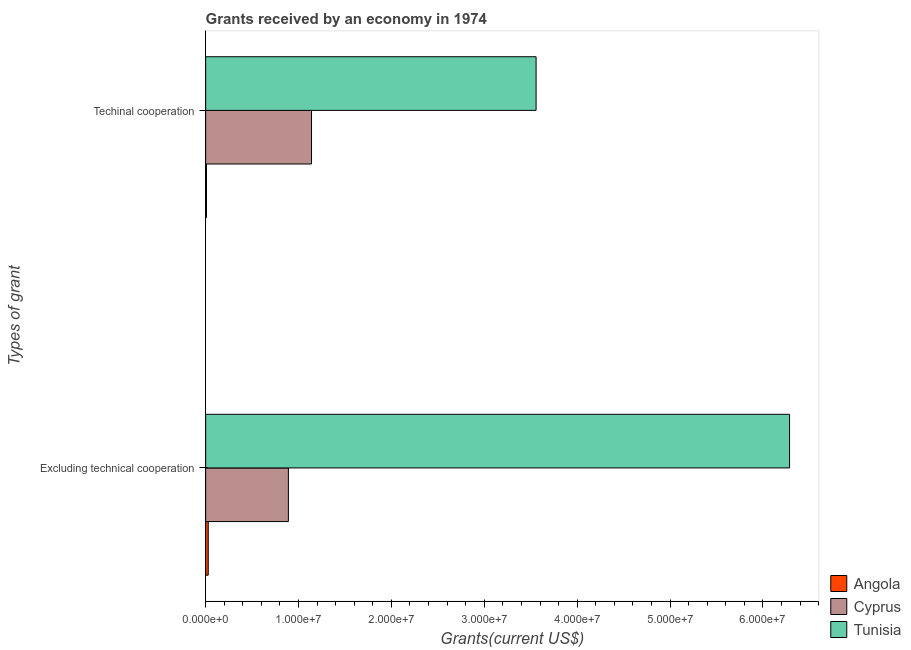How many groups of bars are there?
Make the answer very short. 2. What is the label of the 1st group of bars from the top?
Offer a very short reply. Techinal cooperation. What is the amount of grants received(including technical cooperation) in Tunisia?
Provide a succinct answer. 3.56e+07. Across all countries, what is the maximum amount of grants received(including technical cooperation)?
Your answer should be very brief. 3.56e+07. Across all countries, what is the minimum amount of grants received(excluding technical cooperation)?
Your answer should be compact. 2.80e+05. In which country was the amount of grants received(including technical cooperation) maximum?
Your answer should be compact. Tunisia. In which country was the amount of grants received(excluding technical cooperation) minimum?
Your response must be concise. Angola. What is the total amount of grants received(including technical cooperation) in the graph?
Offer a terse response. 4.71e+07. What is the difference between the amount of grants received(including technical cooperation) in Cyprus and that in Tunisia?
Ensure brevity in your answer.  -2.42e+07. What is the difference between the amount of grants received(including technical cooperation) in Cyprus and the amount of grants received(excluding technical cooperation) in Angola?
Your answer should be compact. 1.11e+07. What is the average amount of grants received(including technical cooperation) per country?
Make the answer very short. 1.57e+07. What is the difference between the amount of grants received(excluding technical cooperation) and amount of grants received(including technical cooperation) in Tunisia?
Your answer should be compact. 2.73e+07. What is the ratio of the amount of grants received(excluding technical cooperation) in Cyprus to that in Tunisia?
Offer a terse response. 0.14. Is the amount of grants received(including technical cooperation) in Tunisia less than that in Angola?
Your answer should be compact. No. What does the 1st bar from the top in Excluding technical cooperation represents?
Provide a succinct answer. Tunisia. What does the 3rd bar from the bottom in Excluding technical cooperation represents?
Your answer should be compact. Tunisia. Are all the bars in the graph horizontal?
Make the answer very short. Yes. How many countries are there in the graph?
Your response must be concise. 3. What is the difference between two consecutive major ticks on the X-axis?
Give a very brief answer. 1.00e+07. How many legend labels are there?
Make the answer very short. 3. What is the title of the graph?
Your answer should be compact. Grants received by an economy in 1974. What is the label or title of the X-axis?
Give a very brief answer. Grants(current US$). What is the label or title of the Y-axis?
Give a very brief answer. Types of grant. What is the Grants(current US$) in Angola in Excluding technical cooperation?
Give a very brief answer. 2.80e+05. What is the Grants(current US$) in Cyprus in Excluding technical cooperation?
Your answer should be very brief. 8.91e+06. What is the Grants(current US$) of Tunisia in Excluding technical cooperation?
Offer a very short reply. 6.29e+07. What is the Grants(current US$) in Cyprus in Techinal cooperation?
Offer a terse response. 1.14e+07. What is the Grants(current US$) in Tunisia in Techinal cooperation?
Your response must be concise. 3.56e+07. Across all Types of grant, what is the maximum Grants(current US$) in Cyprus?
Ensure brevity in your answer.  1.14e+07. Across all Types of grant, what is the maximum Grants(current US$) in Tunisia?
Offer a terse response. 6.29e+07. Across all Types of grant, what is the minimum Grants(current US$) in Angola?
Offer a very short reply. 9.00e+04. Across all Types of grant, what is the minimum Grants(current US$) of Cyprus?
Your answer should be compact. 8.91e+06. Across all Types of grant, what is the minimum Grants(current US$) in Tunisia?
Ensure brevity in your answer.  3.56e+07. What is the total Grants(current US$) in Angola in the graph?
Offer a very short reply. 3.70e+05. What is the total Grants(current US$) of Cyprus in the graph?
Keep it short and to the point. 2.03e+07. What is the total Grants(current US$) in Tunisia in the graph?
Your response must be concise. 9.84e+07. What is the difference between the Grants(current US$) in Angola in Excluding technical cooperation and that in Techinal cooperation?
Provide a succinct answer. 1.90e+05. What is the difference between the Grants(current US$) in Cyprus in Excluding technical cooperation and that in Techinal cooperation?
Your response must be concise. -2.49e+06. What is the difference between the Grants(current US$) in Tunisia in Excluding technical cooperation and that in Techinal cooperation?
Provide a short and direct response. 2.73e+07. What is the difference between the Grants(current US$) of Angola in Excluding technical cooperation and the Grants(current US$) of Cyprus in Techinal cooperation?
Offer a terse response. -1.11e+07. What is the difference between the Grants(current US$) of Angola in Excluding technical cooperation and the Grants(current US$) of Tunisia in Techinal cooperation?
Ensure brevity in your answer.  -3.53e+07. What is the difference between the Grants(current US$) of Cyprus in Excluding technical cooperation and the Grants(current US$) of Tunisia in Techinal cooperation?
Your answer should be compact. -2.67e+07. What is the average Grants(current US$) of Angola per Types of grant?
Give a very brief answer. 1.85e+05. What is the average Grants(current US$) of Cyprus per Types of grant?
Keep it short and to the point. 1.02e+07. What is the average Grants(current US$) in Tunisia per Types of grant?
Ensure brevity in your answer.  4.92e+07. What is the difference between the Grants(current US$) of Angola and Grants(current US$) of Cyprus in Excluding technical cooperation?
Provide a succinct answer. -8.63e+06. What is the difference between the Grants(current US$) of Angola and Grants(current US$) of Tunisia in Excluding technical cooperation?
Your answer should be compact. -6.26e+07. What is the difference between the Grants(current US$) of Cyprus and Grants(current US$) of Tunisia in Excluding technical cooperation?
Ensure brevity in your answer.  -5.40e+07. What is the difference between the Grants(current US$) of Angola and Grants(current US$) of Cyprus in Techinal cooperation?
Your answer should be very brief. -1.13e+07. What is the difference between the Grants(current US$) of Angola and Grants(current US$) of Tunisia in Techinal cooperation?
Provide a short and direct response. -3.55e+07. What is the difference between the Grants(current US$) of Cyprus and Grants(current US$) of Tunisia in Techinal cooperation?
Ensure brevity in your answer.  -2.42e+07. What is the ratio of the Grants(current US$) in Angola in Excluding technical cooperation to that in Techinal cooperation?
Provide a short and direct response. 3.11. What is the ratio of the Grants(current US$) in Cyprus in Excluding technical cooperation to that in Techinal cooperation?
Keep it short and to the point. 0.78. What is the ratio of the Grants(current US$) in Tunisia in Excluding technical cooperation to that in Techinal cooperation?
Make the answer very short. 1.77. What is the difference between the highest and the second highest Grants(current US$) of Angola?
Make the answer very short. 1.90e+05. What is the difference between the highest and the second highest Grants(current US$) in Cyprus?
Offer a very short reply. 2.49e+06. What is the difference between the highest and the second highest Grants(current US$) in Tunisia?
Offer a very short reply. 2.73e+07. What is the difference between the highest and the lowest Grants(current US$) in Cyprus?
Provide a succinct answer. 2.49e+06. What is the difference between the highest and the lowest Grants(current US$) of Tunisia?
Offer a very short reply. 2.73e+07. 